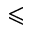Convert formula to latex. <formula><loc_0><loc_0><loc_500><loc_500>\leqslant</formula> 